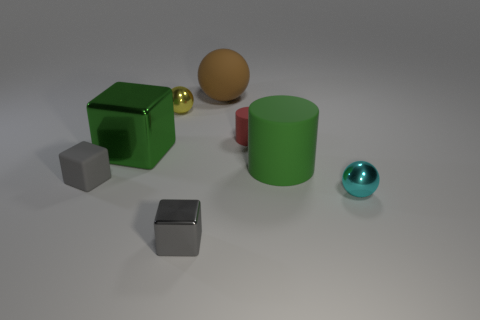Add 1 big brown things. How many objects exist? 9 Subtract all cubes. How many objects are left? 5 Add 3 cyan metallic balls. How many cyan metallic balls exist? 4 Subtract 1 cyan balls. How many objects are left? 7 Subtract all large cyan metal balls. Subtract all small gray matte blocks. How many objects are left? 7 Add 2 cyan things. How many cyan things are left? 3 